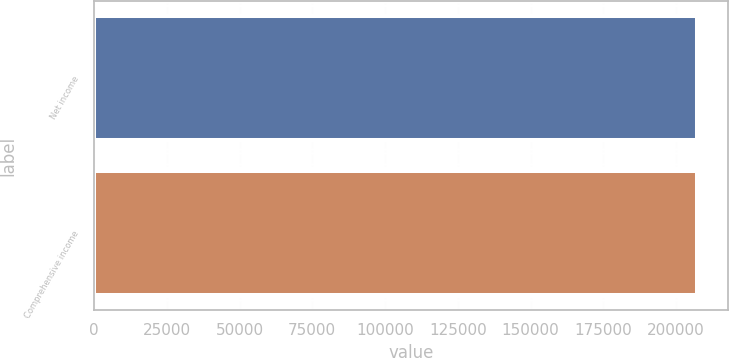Convert chart. <chart><loc_0><loc_0><loc_500><loc_500><bar_chart><fcel>Net income<fcel>Comprehensive income<nl><fcel>207311<fcel>207311<nl></chart> 